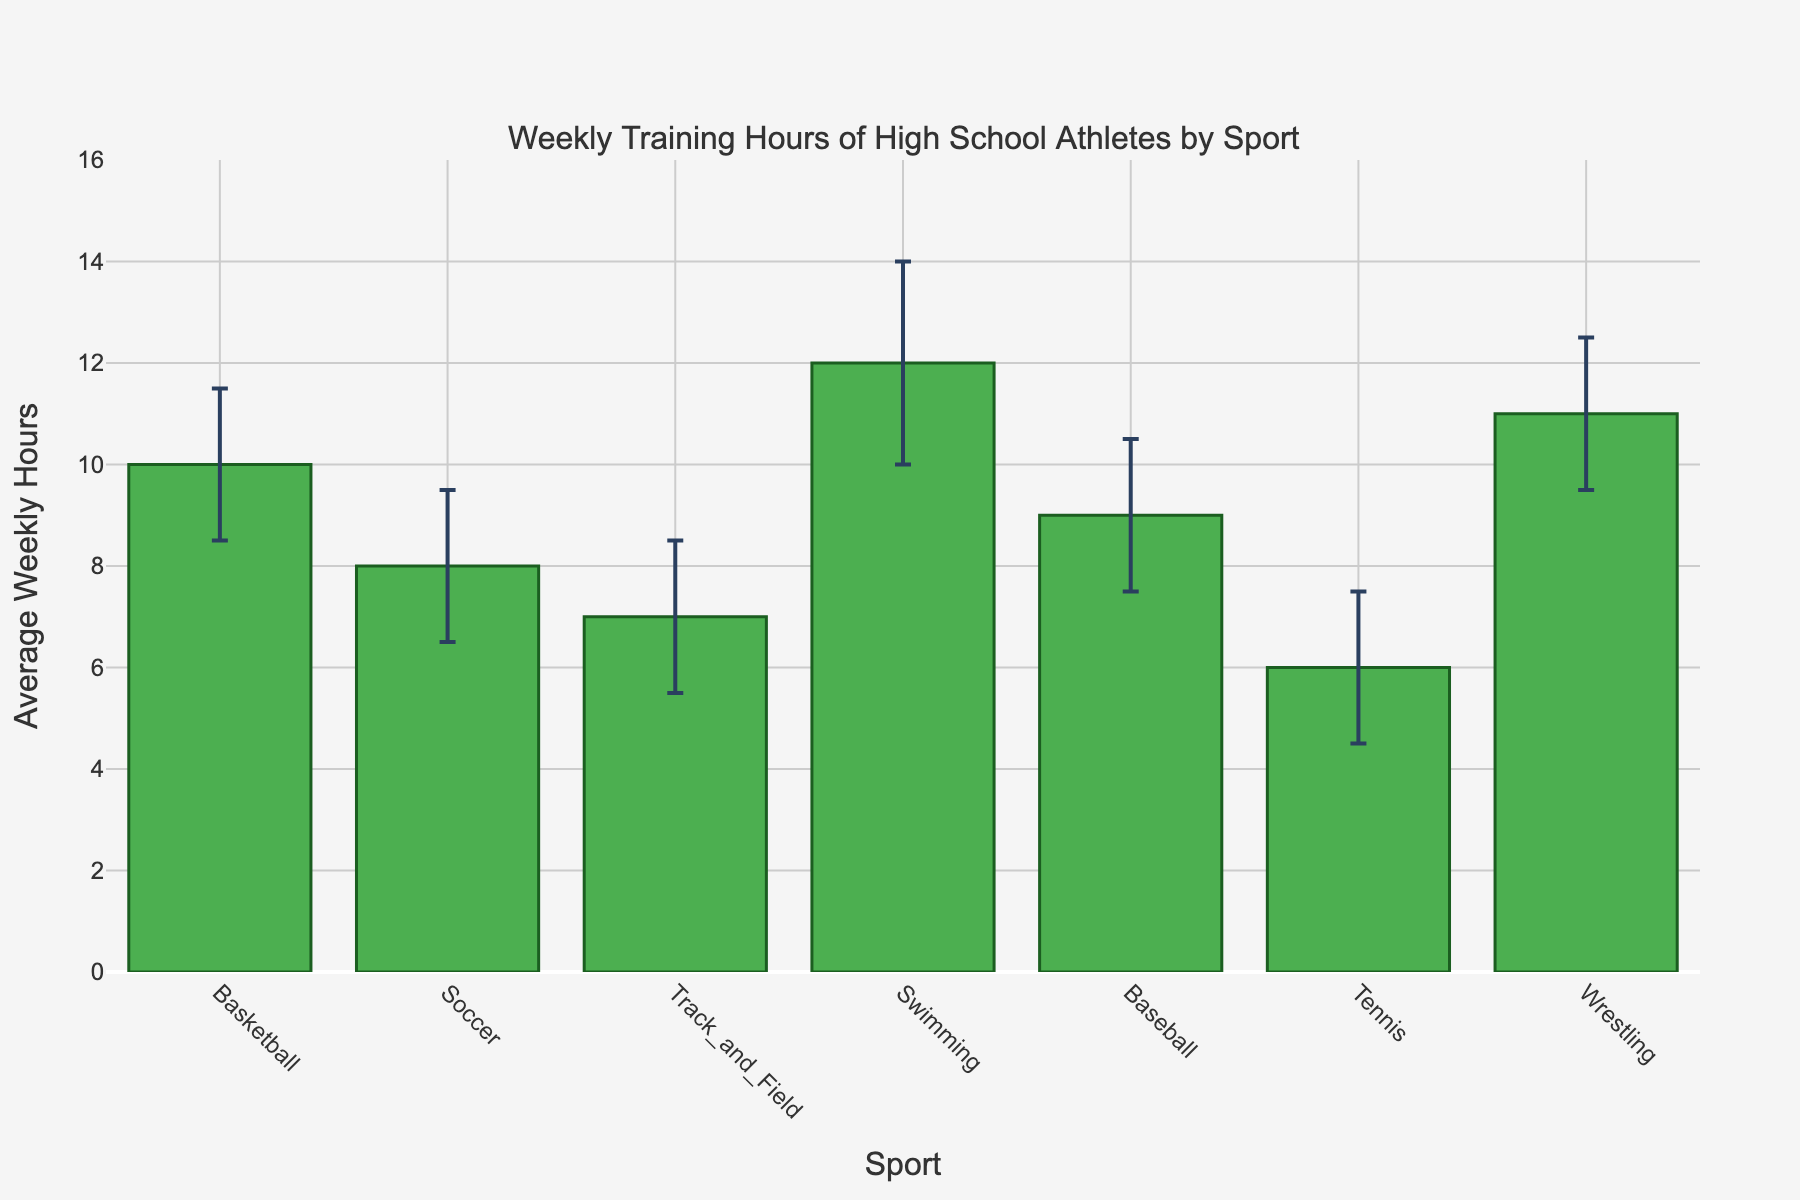What's the title of the chart? The title of the chart is prominently displayed at the top of the figure. It reads "Weekly Training Hours of High School Athletes by Sport."
Answer: Weekly Training Hours of High School Athletes by Sport How many sports are shown in the bar chart? By counting the number of bars (columns) in the chart, we see that each bar represents a different sport. Count each of these for the total.
Answer: 7 Which sport has the highest average weekly training hours? The height of each bar indicates the average weekly training hours for each sport. The bar with the greatest height will represent the sport with the highest average.
Answer: Swimming What is the range of average weekly training hours for Basketball including the confidence interval? The average weekly training hours for Basketball and its confidence intervals are shown. The values are from the figure: low confidence interval (8.5 hours), high confidence interval (11.5 hours).
Answer: 8.5 to 11.5 hours Which sport has the lowest lower bound of the confidence interval? Using the confidence interval lower bounds, compare each sport's lower bound. The sport with the smallest lower bound is the answer.
Answer: Tennis What is the difference in average weekly training hours between Swimming and Tennis? Determine the average weekly hours of both sports from the heights of their respective bars: Swimming (12 hours) and Tennis (6 hours). Subtract Tennis from Swimming for the difference.
Answer: 6 hours What is the sum of the average weekly training hours for Soccer and Baseball? Add the average weekly hours for Soccer (8 hours) and Baseball (9 hours) from the figure.
Answer: 17 hours Which sport's upper confidence interval is closest to the average weekly training hours of Basketball? Compare the upper confidence intervals of each sport with the average weekly hours of Basketball (10 hours). The sport whose upper interval is numerically closest is the answer.
Answer: Wrestling How much wider is the confidence interval range for Swimming compared to Track and Field? Calculate the width of each confidence interval by subtracting the lower bound from the upper bound for each sport. Then, find the difference: Swimming (14 - 10 = 4 hours) and Track and Field (8.5 - 5.5 = 3 hours), hence 4 - 3 = 1 hour.
Answer: 1 hour Is the average weekly training hours for Wrestling more or less than Soccer’s upper confidence interval? Compare the average weekly training hours for Wrestling (11 hours) to Soccer’s upper confidence interval (9.5 hours). Determine if Wrestling's hours are greater or less than Soccer’s upper interval.
Answer: More 